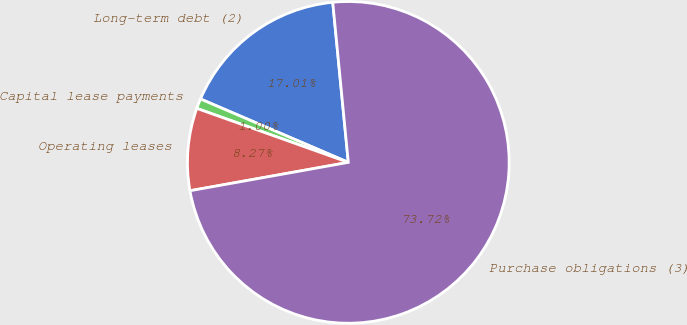Convert chart to OTSL. <chart><loc_0><loc_0><loc_500><loc_500><pie_chart><fcel>Long-term debt (2)<fcel>Capital lease payments<fcel>Operating leases<fcel>Purchase obligations (3)<nl><fcel>17.01%<fcel>1.0%<fcel>8.27%<fcel>73.72%<nl></chart> 